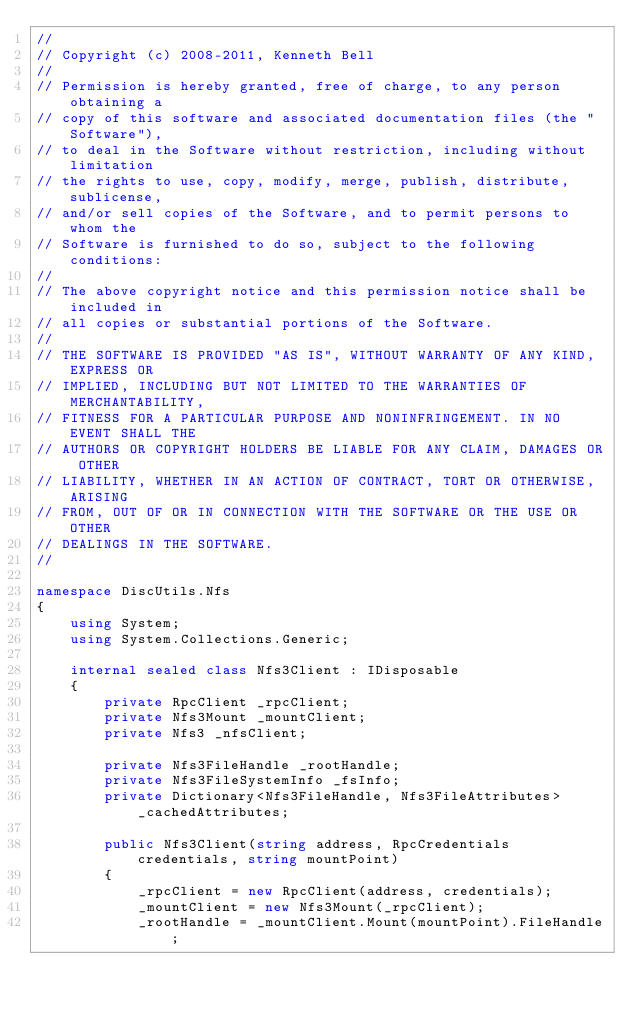<code> <loc_0><loc_0><loc_500><loc_500><_C#_>//
// Copyright (c) 2008-2011, Kenneth Bell
//
// Permission is hereby granted, free of charge, to any person obtaining a
// copy of this software and associated documentation files (the "Software"),
// to deal in the Software without restriction, including without limitation
// the rights to use, copy, modify, merge, publish, distribute, sublicense,
// and/or sell copies of the Software, and to permit persons to whom the
// Software is furnished to do so, subject to the following conditions:
//
// The above copyright notice and this permission notice shall be included in
// all copies or substantial portions of the Software.
//
// THE SOFTWARE IS PROVIDED "AS IS", WITHOUT WARRANTY OF ANY KIND, EXPRESS OR
// IMPLIED, INCLUDING BUT NOT LIMITED TO THE WARRANTIES OF MERCHANTABILITY,
// FITNESS FOR A PARTICULAR PURPOSE AND NONINFRINGEMENT. IN NO EVENT SHALL THE
// AUTHORS OR COPYRIGHT HOLDERS BE LIABLE FOR ANY CLAIM, DAMAGES OR OTHER
// LIABILITY, WHETHER IN AN ACTION OF CONTRACT, TORT OR OTHERWISE, ARISING
// FROM, OUT OF OR IN CONNECTION WITH THE SOFTWARE OR THE USE OR OTHER
// DEALINGS IN THE SOFTWARE.
//

namespace DiscUtils.Nfs
{
    using System;
    using System.Collections.Generic;

    internal sealed class Nfs3Client : IDisposable
    {
        private RpcClient _rpcClient;
        private Nfs3Mount _mountClient;
        private Nfs3 _nfsClient;

        private Nfs3FileHandle _rootHandle;
        private Nfs3FileSystemInfo _fsInfo;
        private Dictionary<Nfs3FileHandle, Nfs3FileAttributes> _cachedAttributes;

        public Nfs3Client(string address, RpcCredentials credentials, string mountPoint)
        {
            _rpcClient = new RpcClient(address, credentials);
            _mountClient = new Nfs3Mount(_rpcClient);
            _rootHandle = _mountClient.Mount(mountPoint).FileHandle;
</code> 